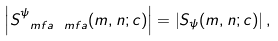Convert formula to latex. <formula><loc_0><loc_0><loc_500><loc_500>\left | S _ { \ m f a \ m f a } ^ { \psi } ( m , n ; c ) \right | = \left | S _ { \psi } ( m , n ; c ) \right | ,</formula> 